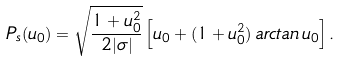Convert formula to latex. <formula><loc_0><loc_0><loc_500><loc_500>P _ { s } ( u _ { 0 } ) = \sqrt { \frac { 1 + u _ { 0 } ^ { 2 } } { 2 | \sigma | } } \left [ u _ { 0 } + ( 1 + u _ { 0 } ^ { 2 } ) \, a r c t a n \, u _ { 0 } \right ] .</formula> 